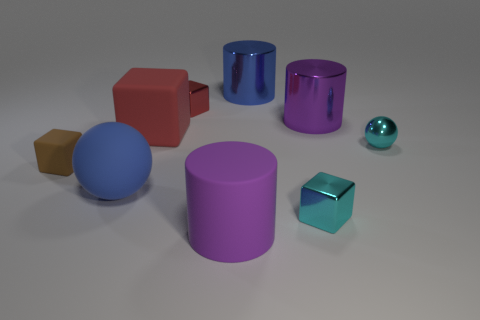Add 1 large gray metal blocks. How many objects exist? 10 Subtract all shiny cylinders. How many cylinders are left? 1 Subtract 2 spheres. How many spheres are left? 0 Subtract all purple cylinders. Subtract all yellow spheres. How many cylinders are left? 1 Subtract all blue cubes. How many cyan spheres are left? 1 Subtract all red cubes. Subtract all gray cylinders. How many objects are left? 7 Add 1 brown blocks. How many brown blocks are left? 2 Add 8 purple shiny cylinders. How many purple shiny cylinders exist? 9 Subtract all brown cubes. How many cubes are left? 3 Subtract 2 red cubes. How many objects are left? 7 